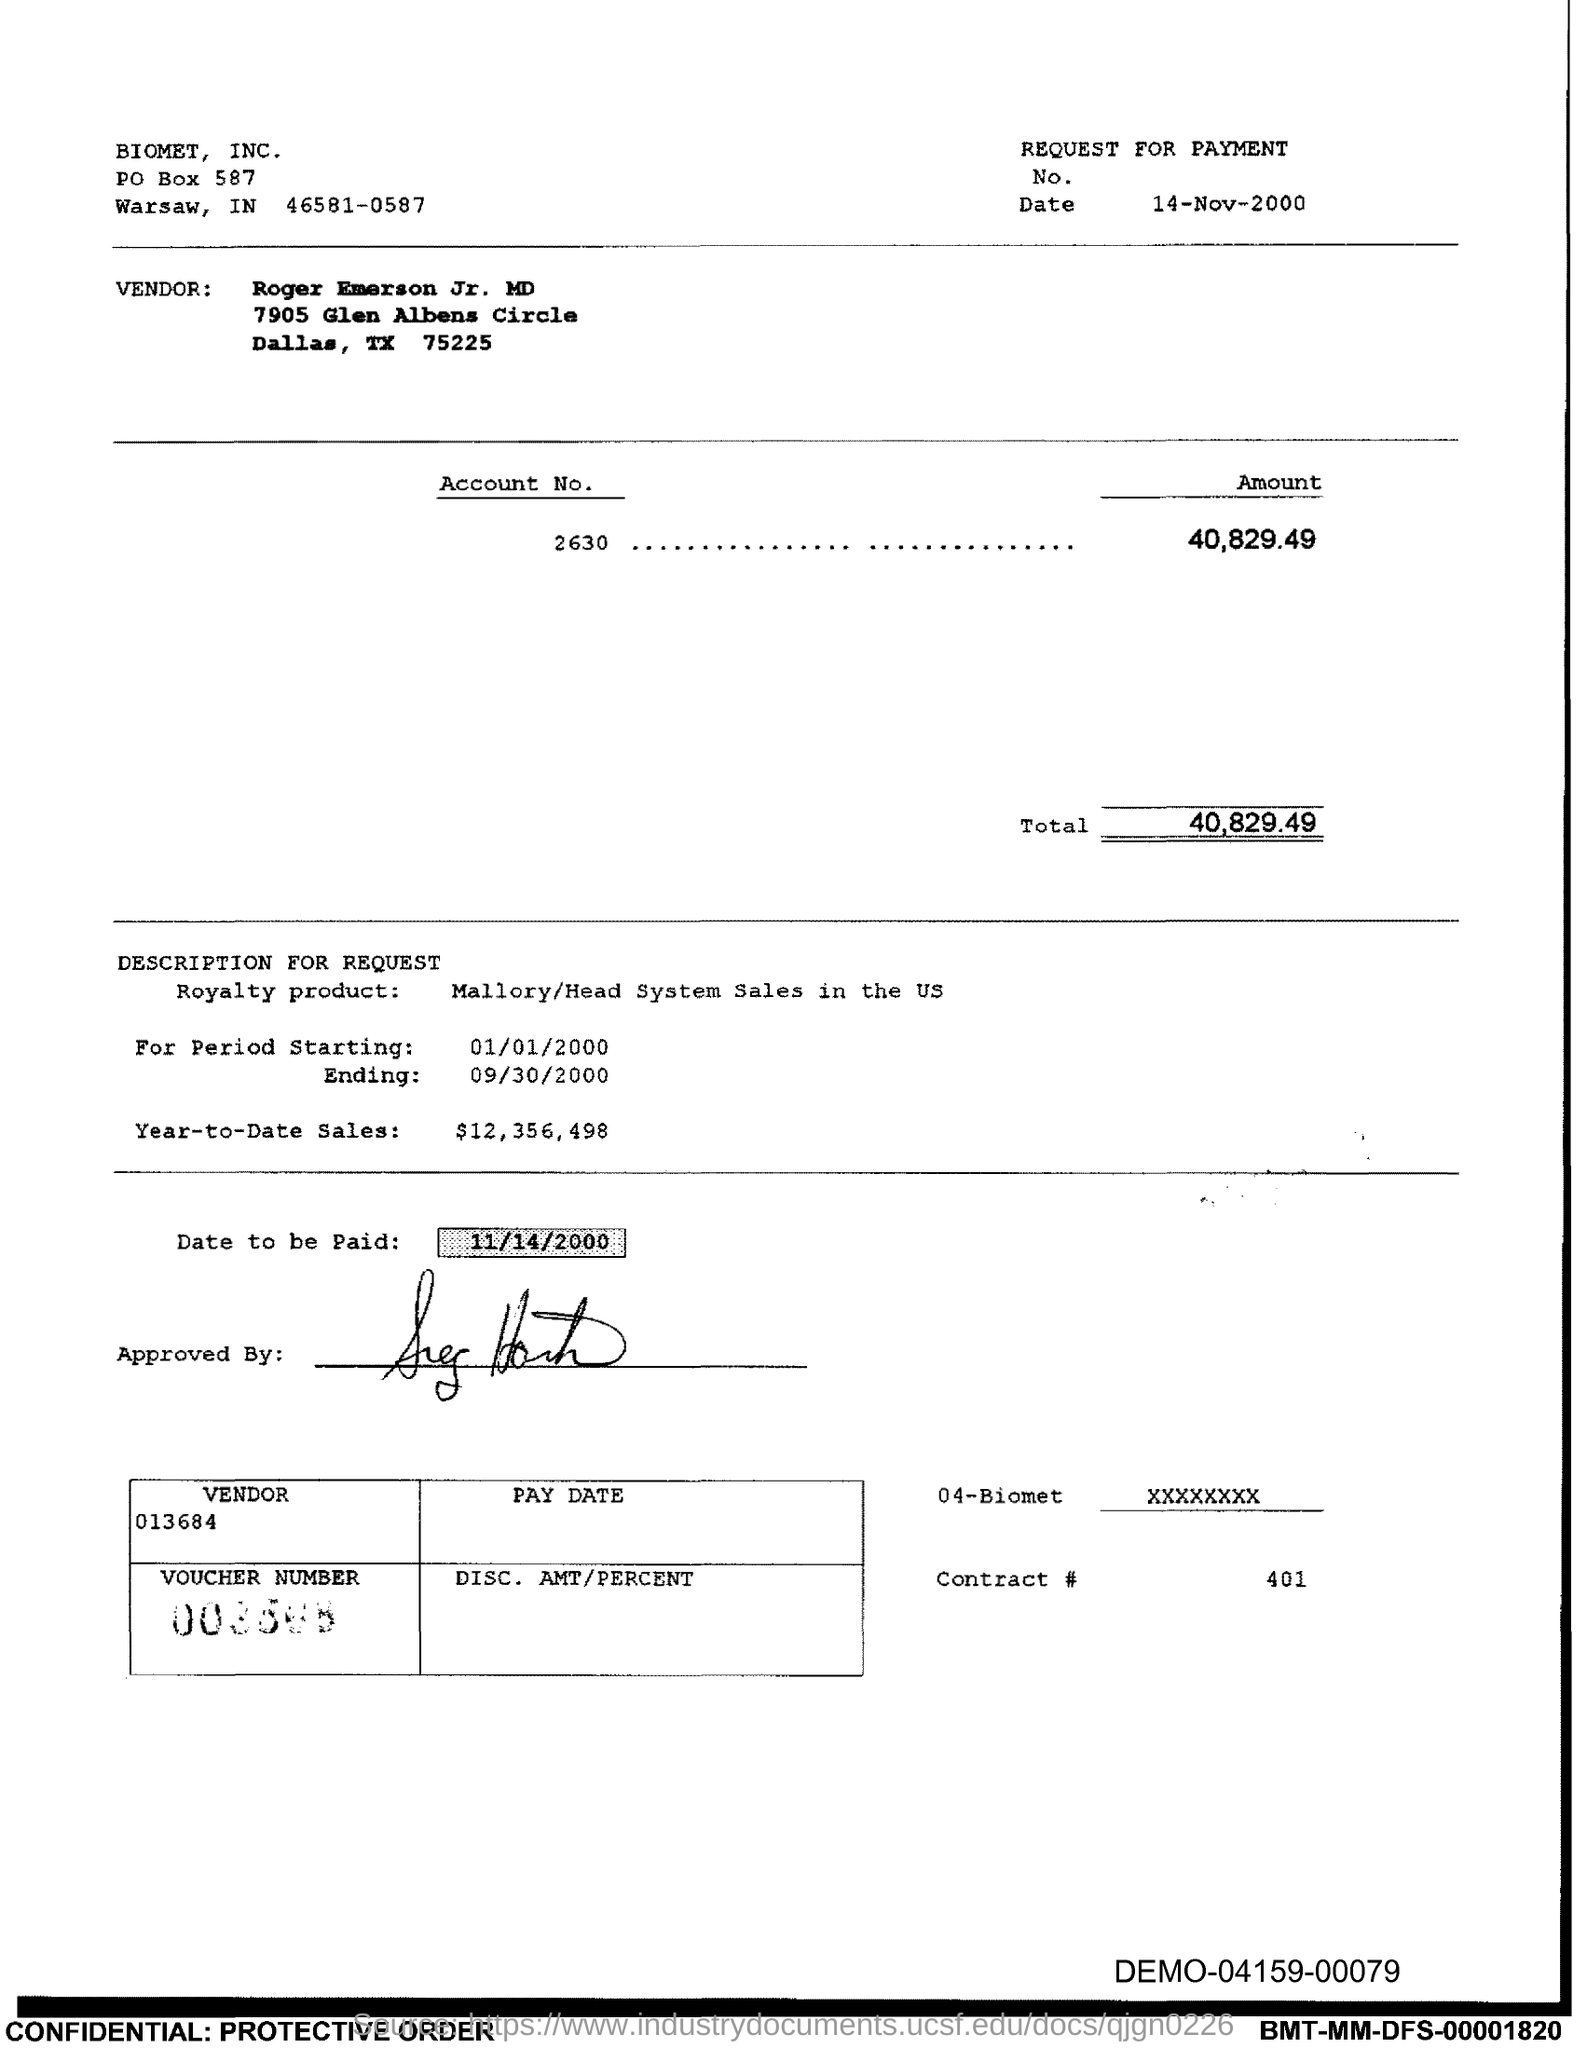Specify some key components in this picture. The document mentions BIOMET, INC. in the header. The total amount to be paid, as indicated on the voucher, is 40,829.49. The royalty product mentioned in the voucher is [insert product name]. The end date of the royalty period is September 30, 2000. The issued date of this voucher is November 14, 2000. 